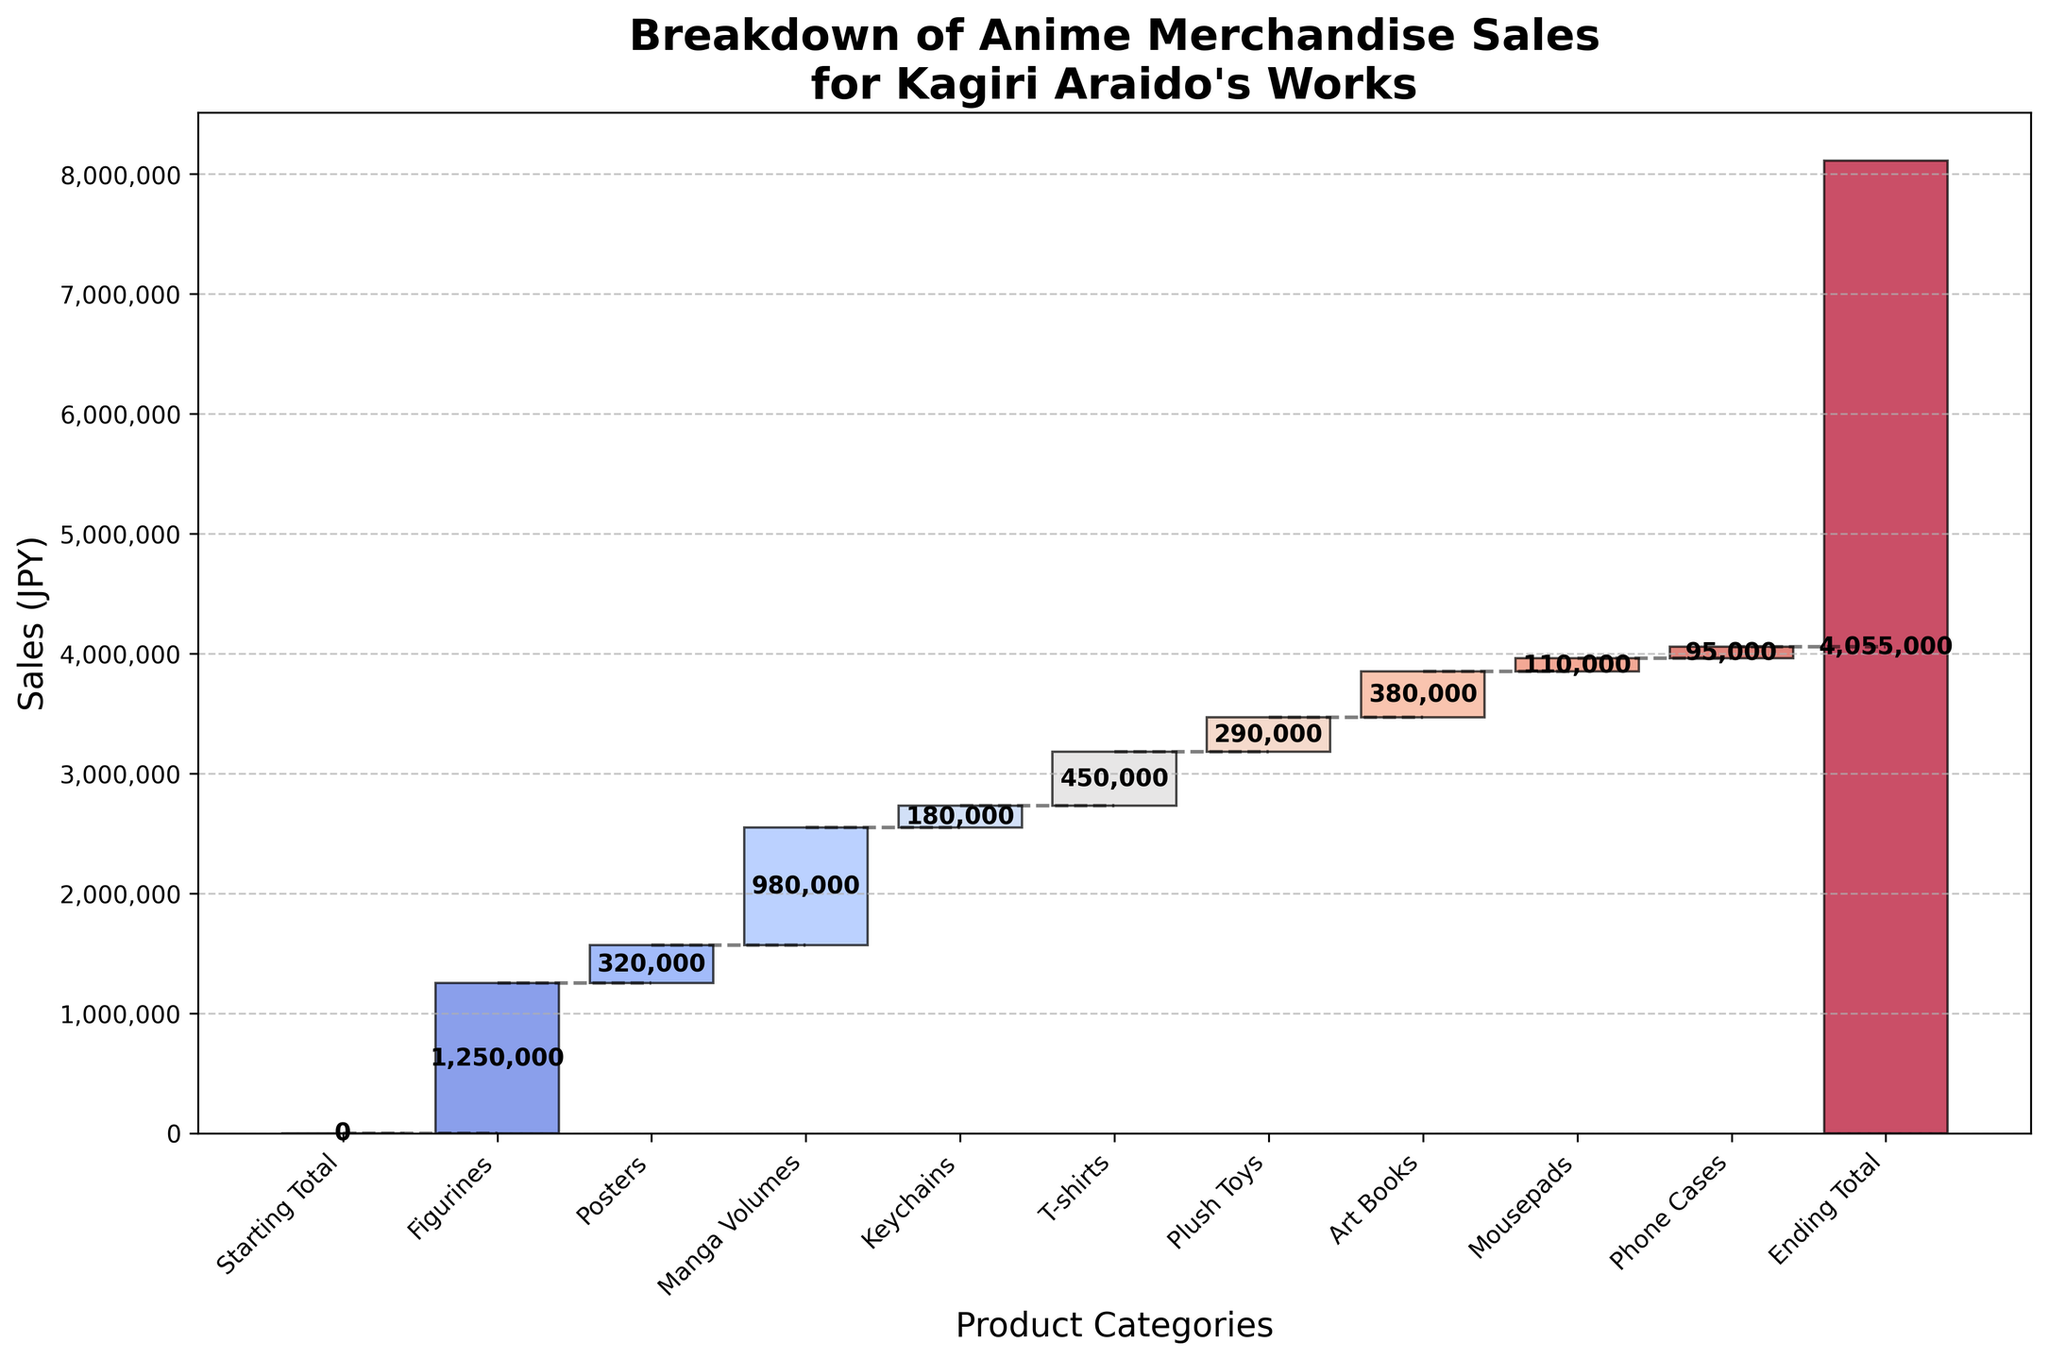What is the title of the waterfall chart? The title of the chart should be located at the top of the figure and is used to indicate what the chart represents.
Answer: Breakdown of Anime Merchandise Sales for Kagiri Araido's Works How many product categories are displayed in the chart? Count the number of distinct product categories listed along the x-axis of the chart. The categories are represented by the labels and bars.
Answer: 9 What is the total value of sales for Figurines? Locate the bar labeled "Figurines" and read the numeric value either on the bar or next to it. This represents the total sales for Figurines.
Answer: 1,250,000 Which product category saw the least amount of sales? Examine and compare the heights of all product category bars to find the shortest one, which indicates the smallest sales amount.
Answer: Phone Cases What is the difference in sales between Manga Volumes and Posters? Identify the sales values for "Manga Volumes" and "Posters", then subtract the smaller sales value from the larger one: 980,000 - 320,000.
Answer: 660,000 How much higher are the sales for T-shirts compared to Keychains? First, find the sales values for both "T-shirts" and "Keychains". Then, subtract the value of Keychains from the value of T-shirts: 450,000 - 180,000.
Answer: 270,000 What is the average sales value of all product categories (excluding Starting and Ending Totals)? Add the sales values of all product categories, then divide by the number of categories: (1,250,000 + 320,000 + 980,000 + 180,000 + 450,000 + 290,000 + 380,000 + 110,000 + 95,000) / 9.
Answer: 450,556 By how much does the Ending Total exceed the Starting Total? The Ending Total is 4,055,000 and the Starting Total is 0. Subtract the Starting Total from the Ending Total: 4,055,000 - 0.
Answer: 4,055,000 What color scheme is used in the chart? The color scheme refers to the combination of colors used to distinguish different bars in the chart. Identify the general palette based on visual inspection.
Answer: Coolwarm How much do sales increase at each step from the Starting Total to the Ending Total? For each step, identify the sales value of the product category bar and add it to the cumulative sum from the previous step. List the individual increments, which match the values of each product category bar.
Answer: Varies by category value 